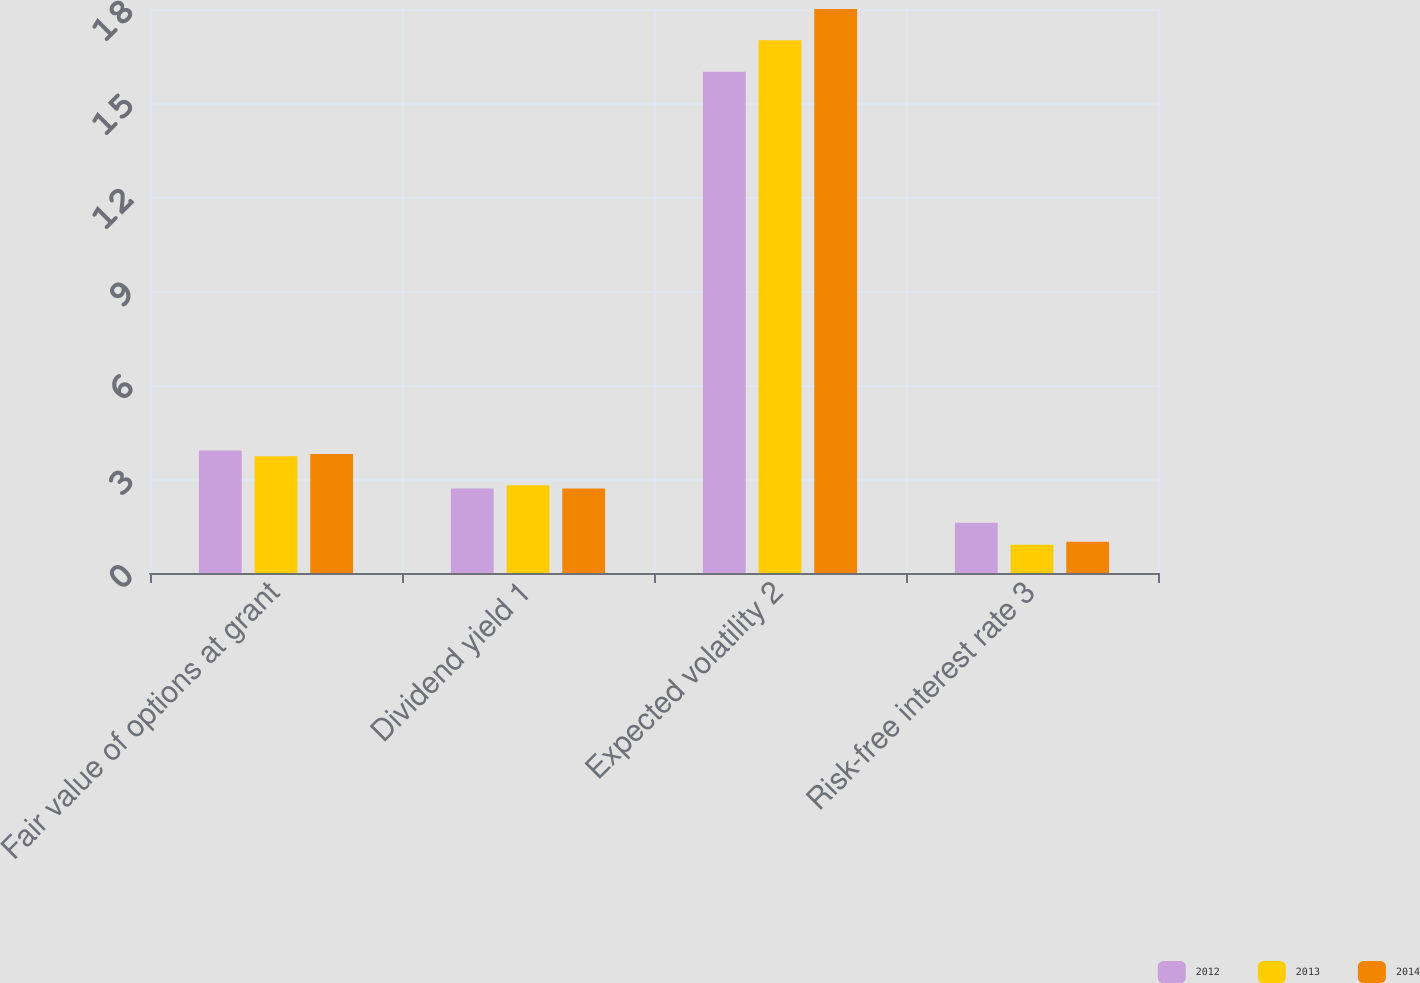Convert chart to OTSL. <chart><loc_0><loc_0><loc_500><loc_500><stacked_bar_chart><ecel><fcel>Fair value of options at grant<fcel>Dividend yield 1<fcel>Expected volatility 2<fcel>Risk-free interest rate 3<nl><fcel>2012<fcel>3.91<fcel>2.7<fcel>16<fcel>1.6<nl><fcel>2013<fcel>3.73<fcel>2.8<fcel>17<fcel>0.9<nl><fcel>2014<fcel>3.8<fcel>2.7<fcel>18<fcel>1<nl></chart> 